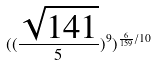Convert formula to latex. <formula><loc_0><loc_0><loc_500><loc_500>( ( \frac { \sqrt { 1 4 1 } } { 5 } ) ^ { 9 } ) ^ { \frac { 6 } { 1 5 9 } / 1 0 }</formula> 